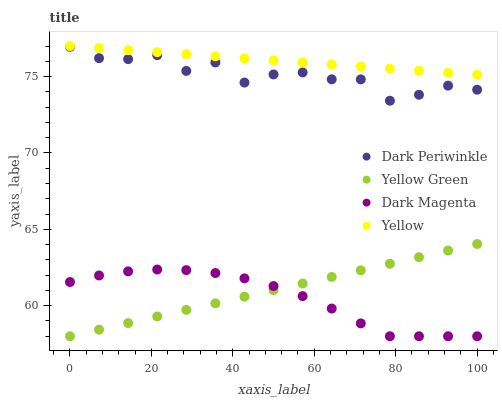Does Dark Magenta have the minimum area under the curve?
Answer yes or no. Yes. Does Yellow have the maximum area under the curve?
Answer yes or no. Yes. Does Dark Periwinkle have the minimum area under the curve?
Answer yes or no. No. Does Dark Periwinkle have the maximum area under the curve?
Answer yes or no. No. Is Yellow the smoothest?
Answer yes or no. Yes. Is Dark Periwinkle the roughest?
Answer yes or no. Yes. Is Dark Magenta the smoothest?
Answer yes or no. No. Is Dark Magenta the roughest?
Answer yes or no. No. Does Dark Magenta have the lowest value?
Answer yes or no. Yes. Does Dark Periwinkle have the lowest value?
Answer yes or no. No. Does Yellow have the highest value?
Answer yes or no. Yes. Does Dark Periwinkle have the highest value?
Answer yes or no. No. Is Dark Periwinkle less than Yellow?
Answer yes or no. Yes. Is Yellow greater than Dark Periwinkle?
Answer yes or no. Yes. Does Yellow Green intersect Dark Magenta?
Answer yes or no. Yes. Is Yellow Green less than Dark Magenta?
Answer yes or no. No. Is Yellow Green greater than Dark Magenta?
Answer yes or no. No. Does Dark Periwinkle intersect Yellow?
Answer yes or no. No. 